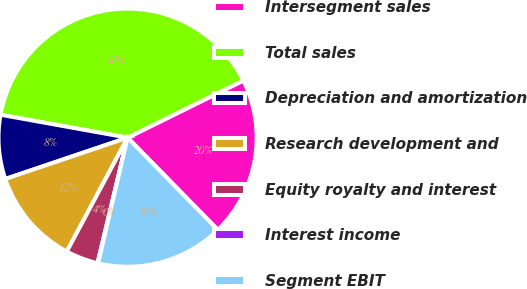<chart> <loc_0><loc_0><loc_500><loc_500><pie_chart><fcel>Intersegment sales<fcel>Total sales<fcel>Depreciation and amortization<fcel>Research development and<fcel>Equity royalty and interest<fcel>Interest income<fcel>Segment EBIT<nl><fcel>19.97%<fcel>39.86%<fcel>8.03%<fcel>12.01%<fcel>4.06%<fcel>0.08%<fcel>15.99%<nl></chart> 